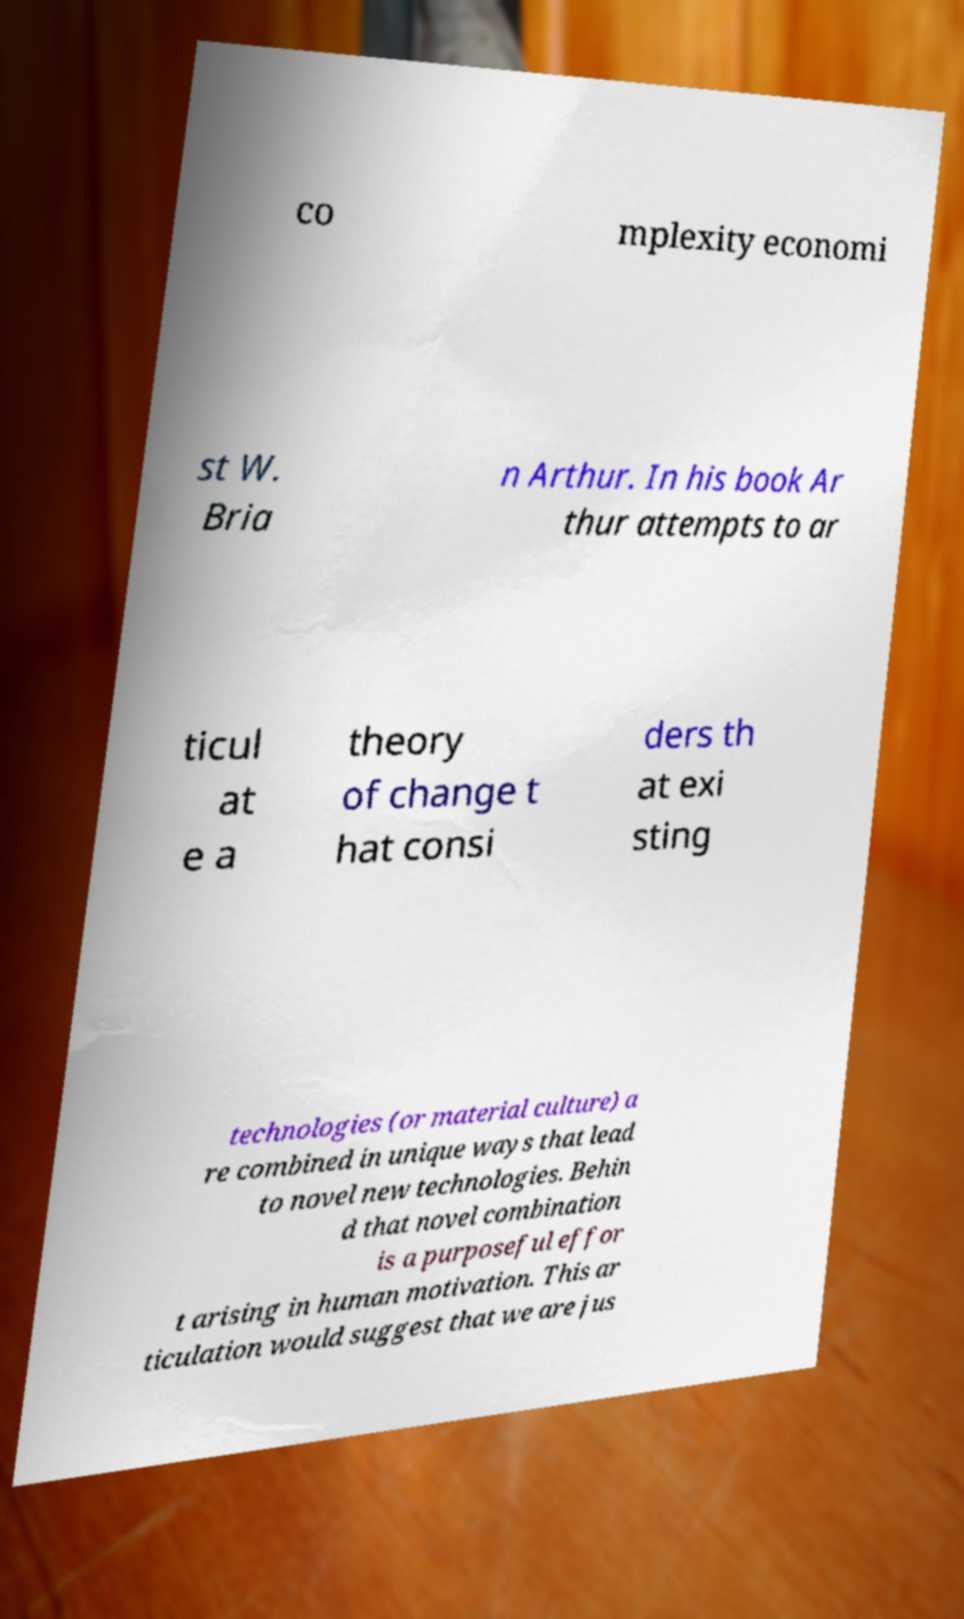Can you read and provide the text displayed in the image?This photo seems to have some interesting text. Can you extract and type it out for me? co mplexity economi st W. Bria n Arthur. In his book Ar thur attempts to ar ticul at e a theory of change t hat consi ders th at exi sting technologies (or material culture) a re combined in unique ways that lead to novel new technologies. Behin d that novel combination is a purposeful effor t arising in human motivation. This ar ticulation would suggest that we are jus 